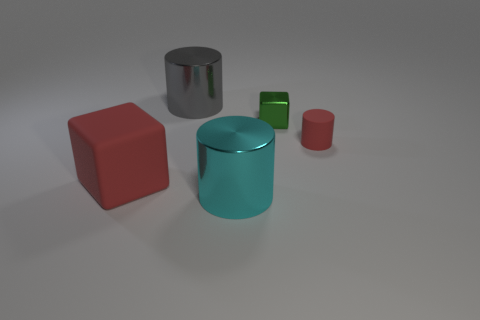Subtract all shiny cylinders. How many cylinders are left? 1 Add 4 green cubes. How many objects exist? 9 Subtract all cylinders. How many objects are left? 2 Subtract 2 cylinders. How many cylinders are left? 1 Add 2 small green matte cubes. How many small green matte cubes exist? 2 Subtract all red cylinders. How many cylinders are left? 2 Subtract 0 blue cylinders. How many objects are left? 5 Subtract all purple cylinders. Subtract all brown blocks. How many cylinders are left? 3 Subtract all big yellow spheres. Subtract all big cyan things. How many objects are left? 4 Add 4 gray cylinders. How many gray cylinders are left? 5 